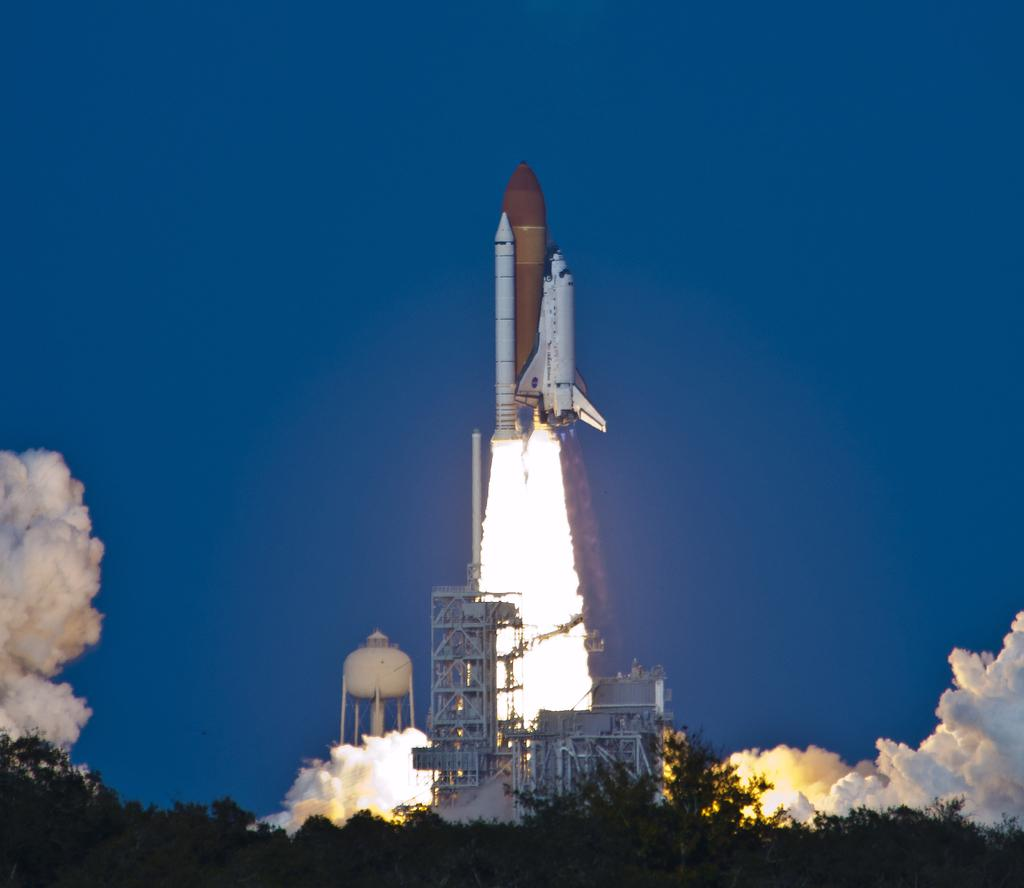What is the main subject of the image? There is a rocket in the image. What else can be seen in the image besides the rocket? There are trees, smoke, iron rods, and the sky in the image. What is the color of the sky in the image? The sky is blue in color. What type of underwear is hanging on the iron rods in the image? There are no underwear items present in the image; only a rocket, trees, smoke, iron rods, and the blue sky can be seen. 